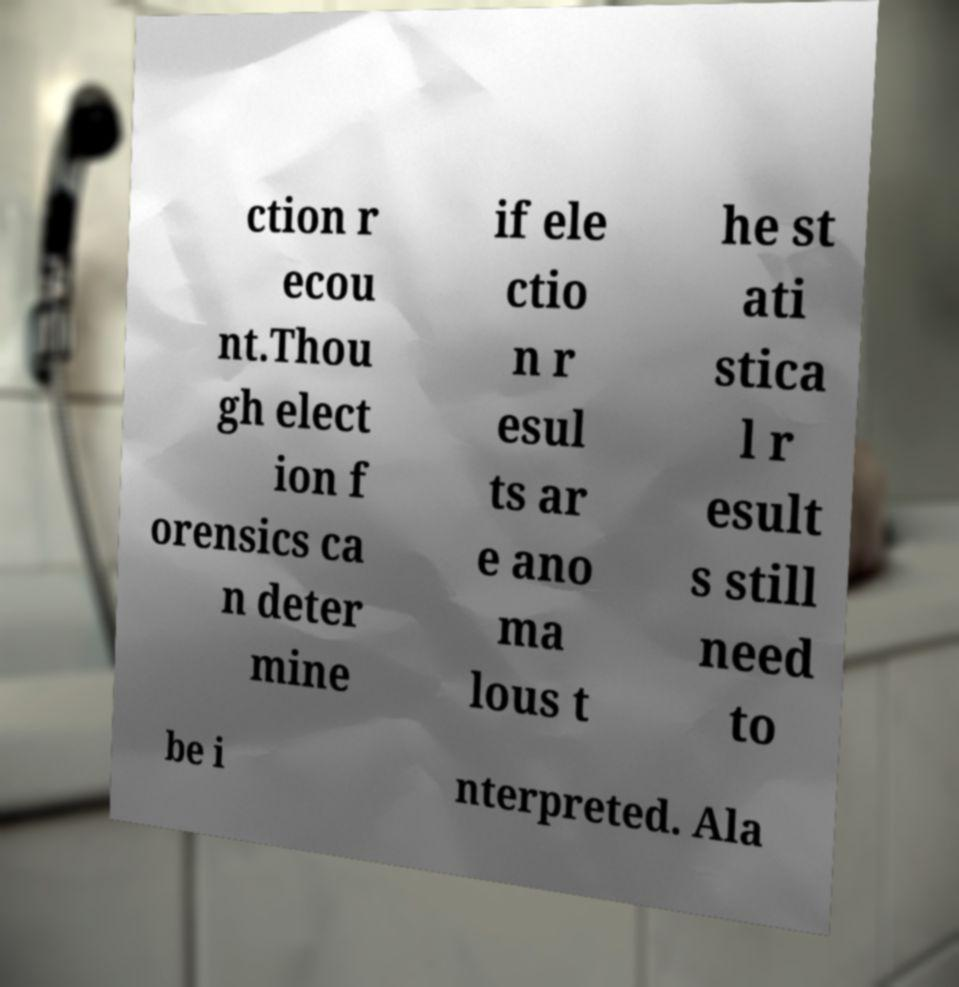Could you extract and type out the text from this image? ction r ecou nt.Thou gh elect ion f orensics ca n deter mine if ele ctio n r esul ts ar e ano ma lous t he st ati stica l r esult s still need to be i nterpreted. Ala 